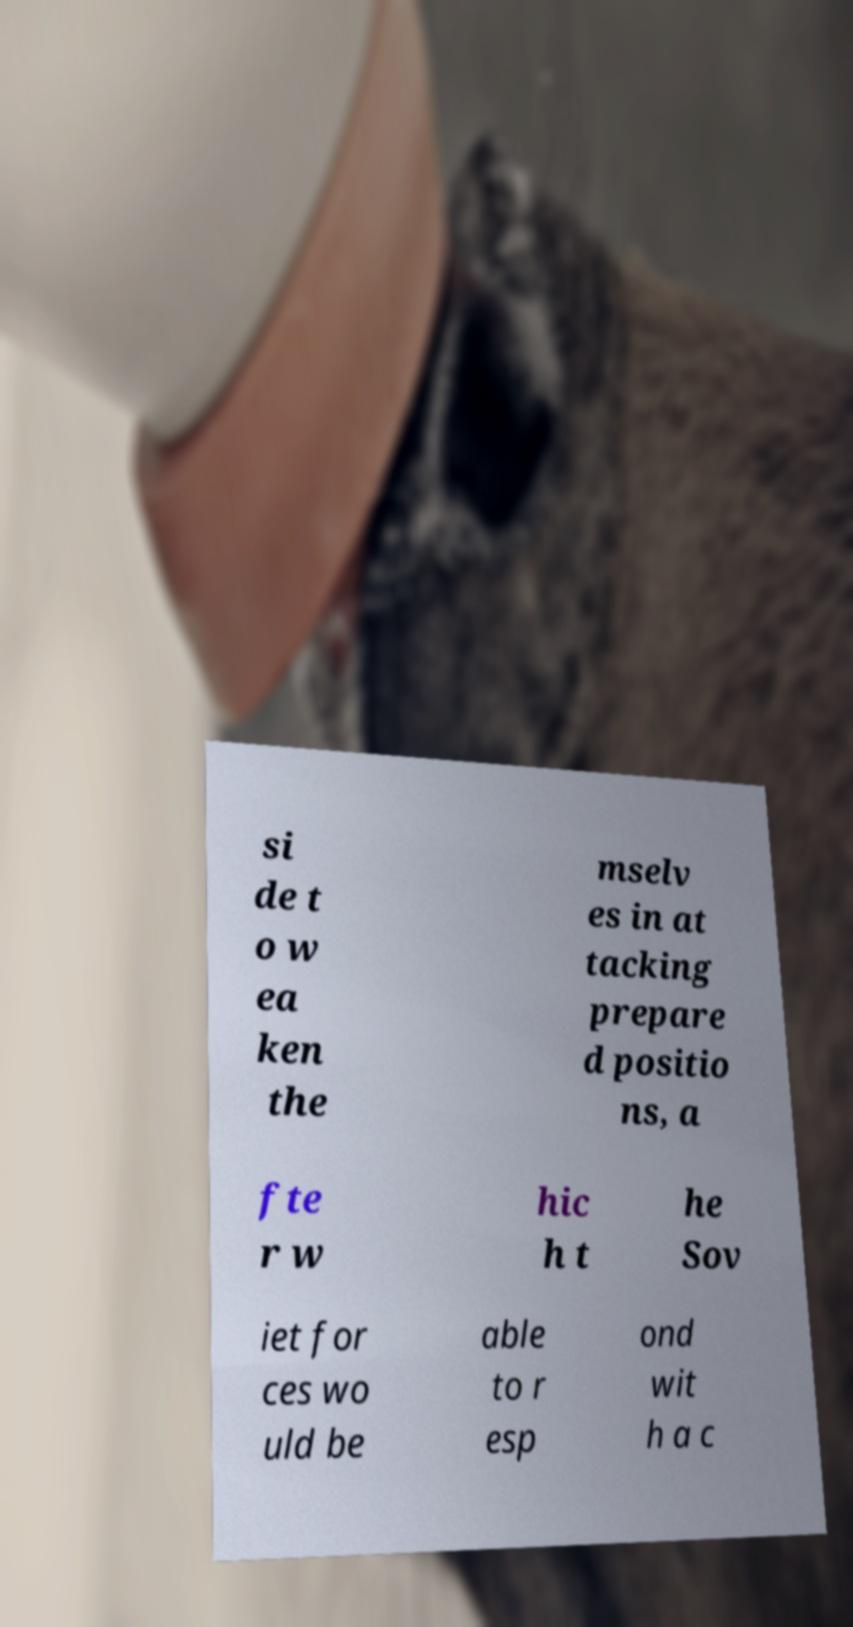What messages or text are displayed in this image? I need them in a readable, typed format. si de t o w ea ken the mselv es in at tacking prepare d positio ns, a fte r w hic h t he Sov iet for ces wo uld be able to r esp ond wit h a c 